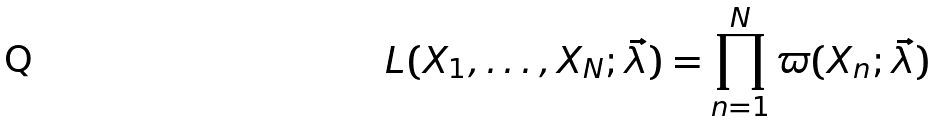Convert formula to latex. <formula><loc_0><loc_0><loc_500><loc_500>L ( X _ { 1 } , \dots , X _ { N } ; \vec { \lambda } ) = \prod _ { n = 1 } ^ { N } \varpi ( X _ { n } ; \vec { \lambda } )</formula> 